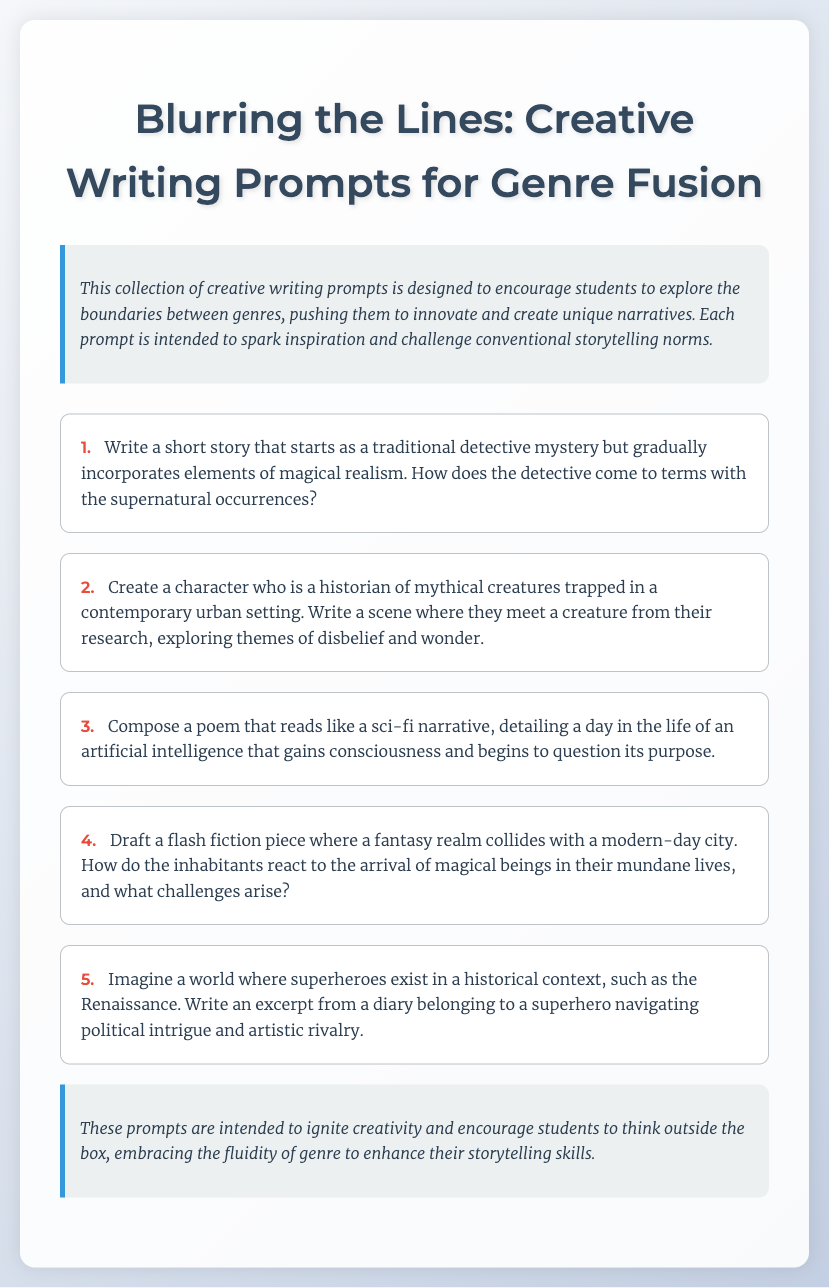what is the title of the document? The title of the document is stated in the header section of the HTML, which is "Blurring the Lines: Creative Writing Prompts for Genre Fusion."
Answer: Blurring the Lines: Creative Writing Prompts for Genre Fusion how many writing prompts are provided in the document? The document lists five writing prompts, each numbered sequentially from 1 to 5.
Answer: 5 what genre is combined with detective mystery in the first prompt? The first prompt specifically mentions the incorporation of elements of magical realism into a traditional detective mystery.
Answer: magical realism what type of writing is encouraged in the third prompt? The third prompt encourages composing a poem that reads like a narrative, specifically a sci-fi narrative detailing an AI's consciousness.
Answer: poem which historical context is suggested for superheroes in the fifth prompt? The fifth prompt suggests a historical context during the Renaissance for the existence of superheroes.
Answer: Renaissance 